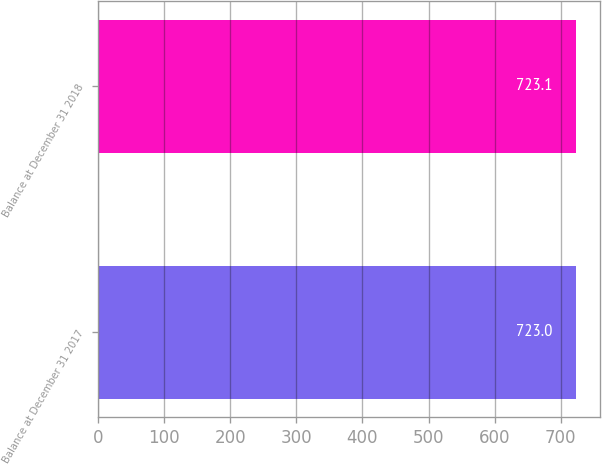Convert chart to OTSL. <chart><loc_0><loc_0><loc_500><loc_500><bar_chart><fcel>Balance at December 31 2017<fcel>Balance at December 31 2018<nl><fcel>723<fcel>723.1<nl></chart> 